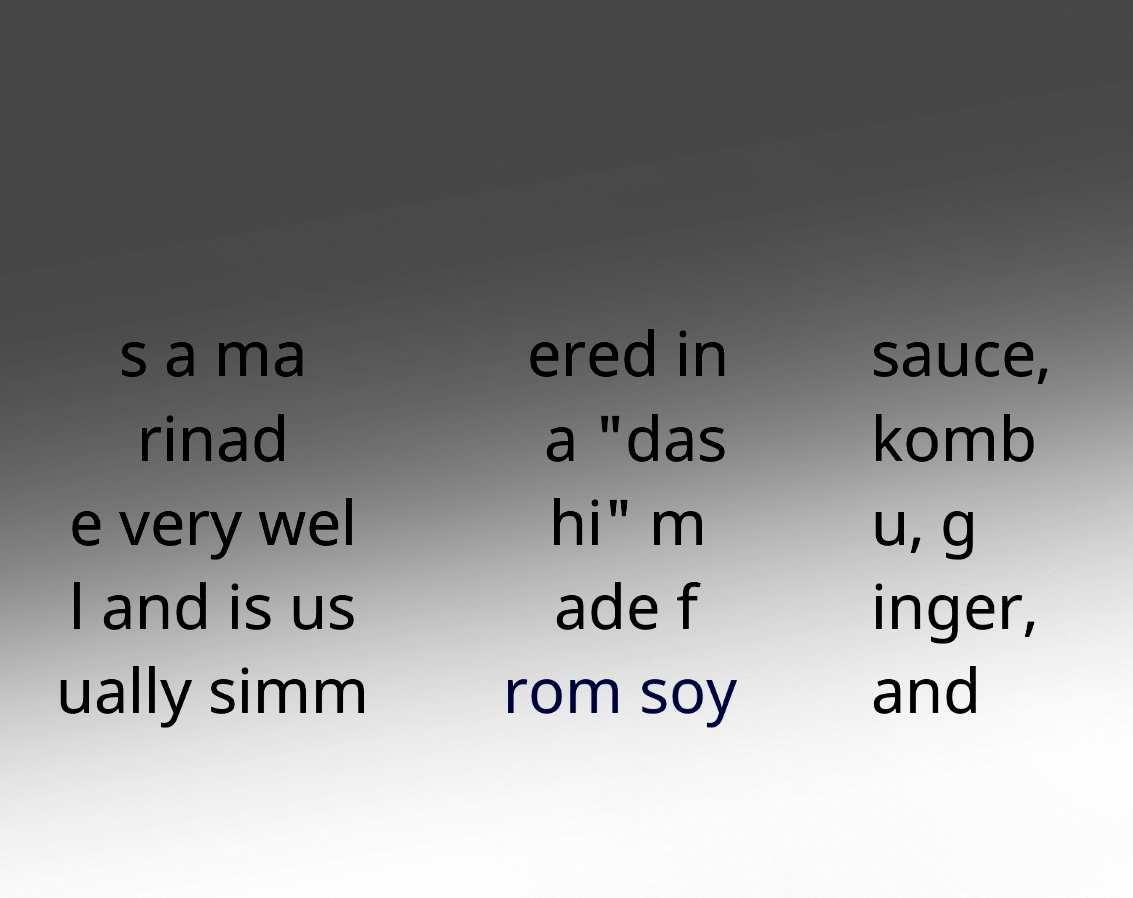Can you accurately transcribe the text from the provided image for me? s a ma rinad e very wel l and is us ually simm ered in a "das hi" m ade f rom soy sauce, komb u, g inger, and 